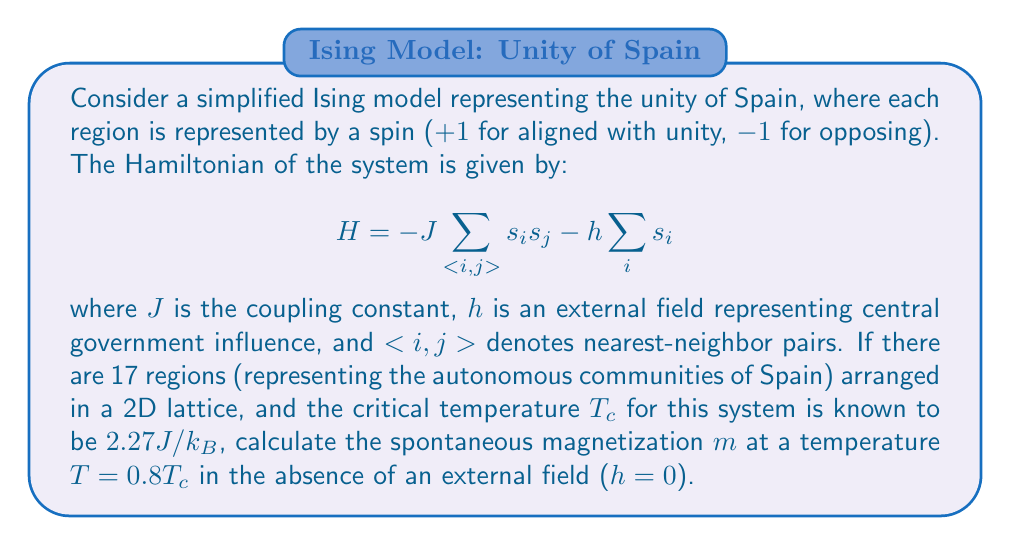Solve this math problem. To solve this problem, we'll use the following steps:

1) First, we need to recognize that this is a 2D Ising model problem below the critical temperature, which means the system is in the ordered (ferromagnetic) phase.

2) The spontaneous magnetization $m$ for a 2D Ising model below $T_c$ is given by the equation:

   $$m(T) = [1 - \sinh^{-4}(2J/k_BT)]^{1/8}$$

3) We're given that $T = 0.8T_c$, and $T_c = 2.27J/k_B$. Let's substitute this:

   $$T = 0.8 \cdot 2.27J/k_B = 1.816J/k_B$$

4) Now, let's substitute this into our equation for $m(T)$:

   $$m(T) = [1 - \sinh^{-4}(2J/k_B \cdot k_BT/J)]^{1/8}$$
   $$= [1 - \sinh^{-4}(2 \cdot 1.816)]^{1/8}$$
   $$= [1 - \sinh^{-4}(3.632)]^{1/8}$$

5) Let's calculate this step by step:
   
   $\sinh(3.632) \approx 18.884$
   $18.884^{-4} \approx 7.84 \times 10^{-7}$
   $1 - 7.84 \times 10^{-7} \approx 0.999999216$
   $(0.999999216)^{1/8} \approx 0.9999999$

6) Therefore, the spontaneous magnetization $m$ at $T = 0.8T_c$ is approximately 0.9999999.

This high value (very close to 1) indicates strong alignment of spins, symbolizing strong unity in our analogy.
Answer: $m \approx 0.9999999$ 